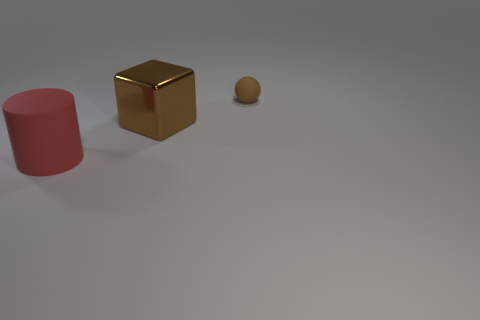Add 1 small gray shiny blocks. How many objects exist? 4 Subtract 1 cubes. How many cubes are left? 0 Subtract all spheres. How many objects are left? 2 Subtract all red balls. How many green cylinders are left? 0 Subtract all tiny brown things. Subtract all brown things. How many objects are left? 0 Add 3 large cylinders. How many large cylinders are left? 4 Add 2 brown matte objects. How many brown matte objects exist? 3 Subtract 0 gray balls. How many objects are left? 3 Subtract all yellow spheres. Subtract all green cylinders. How many spheres are left? 1 